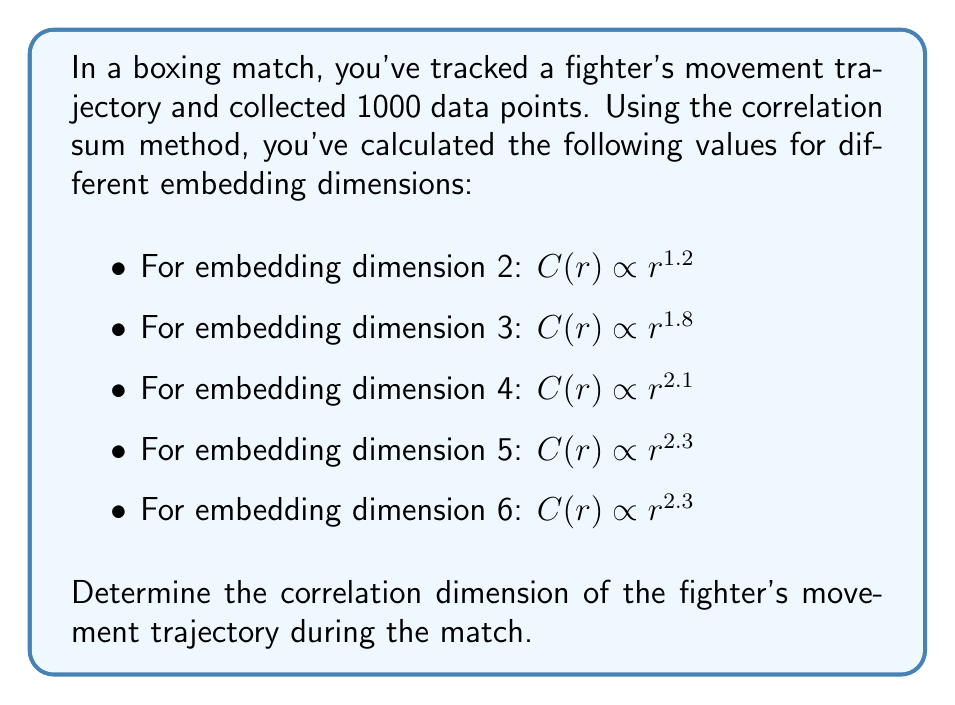Could you help me with this problem? To determine the correlation dimension, we need to follow these steps:

1. Understand the correlation sum method:
   The correlation sum $C(r)$ is proportional to $r^D$, where $r$ is the radius and $D$ is the correlation dimension.

2. Observe the pattern in the given data:
   As the embedding dimension increases, the exponent (which represents the dimension) also increases until it saturates.

3. Identify the saturation point:
   The correlation dimension is the value at which the exponent stops increasing significantly with higher embedding dimensions.

4. Analyze the given data:
   Embedding dimension 2: $D = 1.2$
   Embedding dimension 3: $D = 1.8$
   Embedding dimension 4: $D = 2.1$
   Embedding dimension 5: $D = 2.3$
   Embedding dimension 6: $D = 2.3$

5. Determine the saturation point:
   We can see that the exponent saturates at 2.3 for embedding dimensions 5 and 6.

Therefore, the correlation dimension of the fighter's movement trajectory is 2.3.

This value suggests that the fighter's movement pattern is more complex than a simple line (dimension 1) or plane (dimension 2), but less complex than a fully three-dimensional motion. This could indicate that while the fighter utilizes the ring space effectively, their movement is somewhat constrained, possibly due to strategic positioning or the opponent's pressure.
Answer: 2.3 